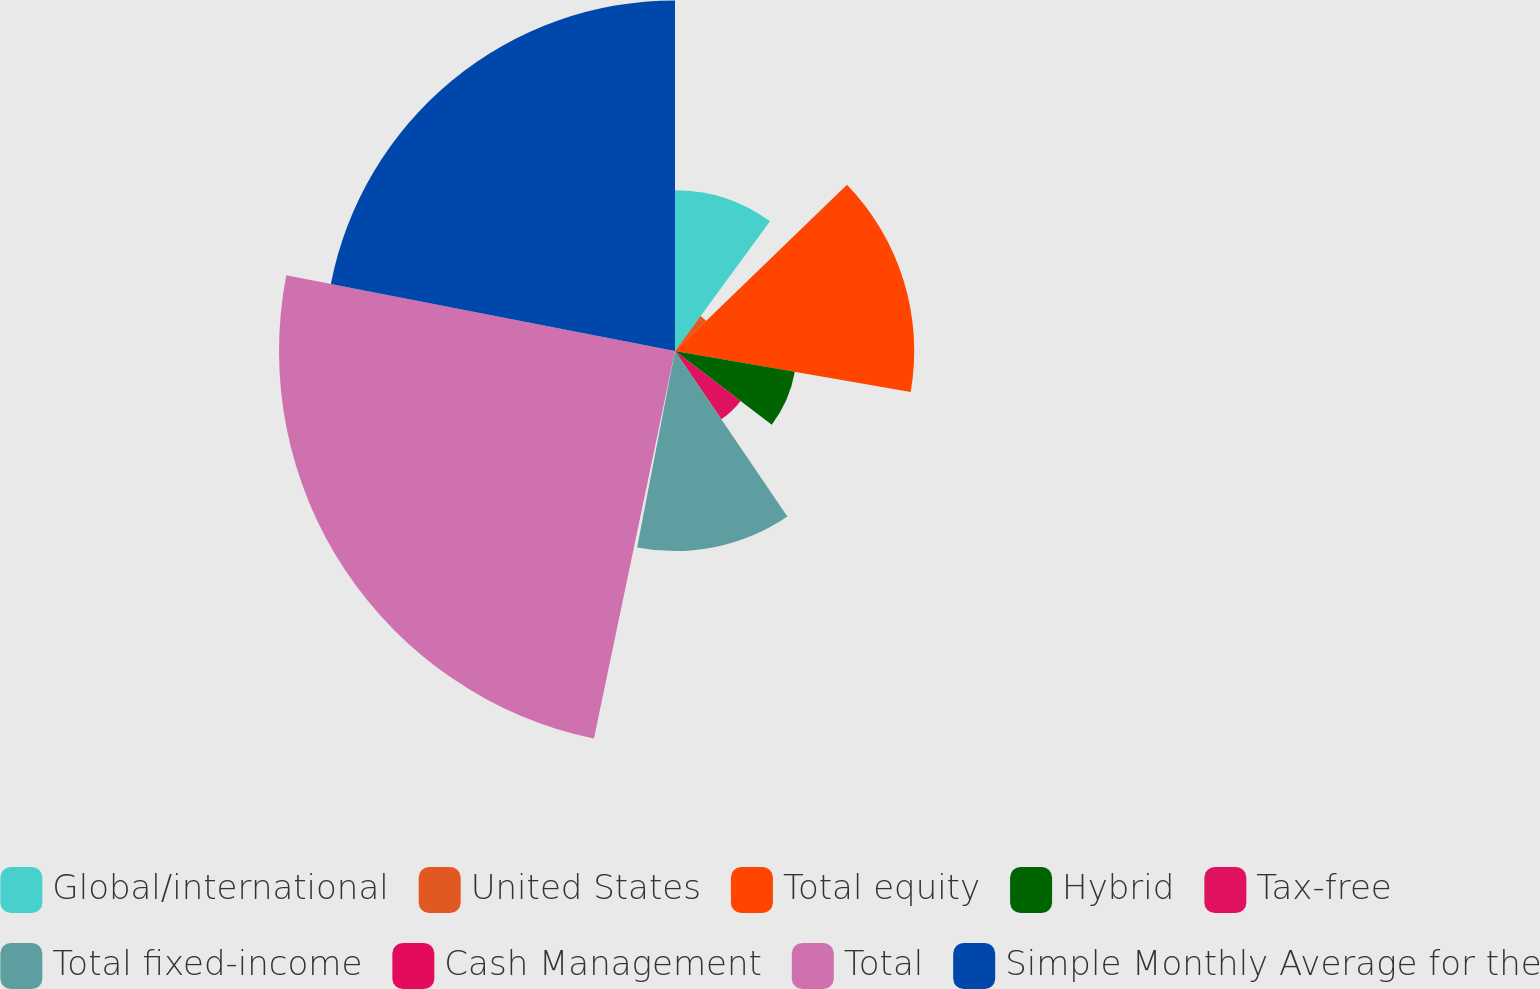Convert chart. <chart><loc_0><loc_0><loc_500><loc_500><pie_chart><fcel>Global/international<fcel>United States<fcel>Total equity<fcel>Hybrid<fcel>Tax-free<fcel>Total fixed-income<fcel>Cash Management<fcel>Total<fcel>Simple Monthly Average for the<nl><fcel>10.06%<fcel>2.71%<fcel>14.97%<fcel>7.61%<fcel>5.16%<fcel>12.52%<fcel>0.25%<fcel>24.78%<fcel>21.94%<nl></chart> 